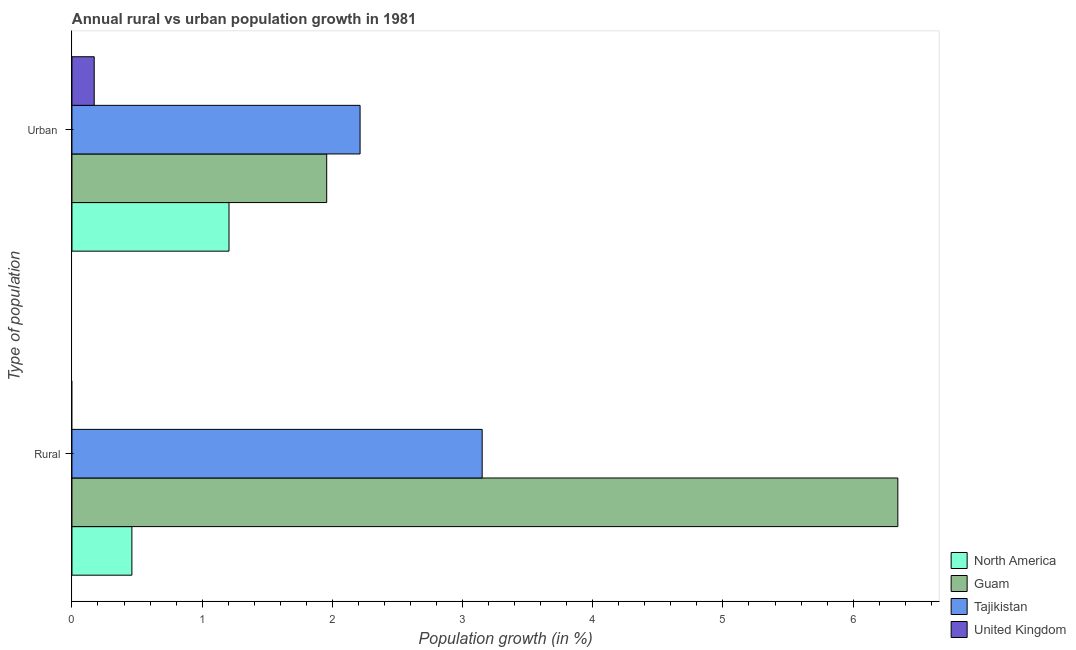How many groups of bars are there?
Ensure brevity in your answer.  2. How many bars are there on the 2nd tick from the bottom?
Offer a very short reply. 4. What is the label of the 1st group of bars from the top?
Your answer should be very brief. Urban . What is the rural population growth in North America?
Provide a succinct answer. 0.46. Across all countries, what is the maximum urban population growth?
Make the answer very short. 2.21. Across all countries, what is the minimum urban population growth?
Offer a terse response. 0.17. In which country was the rural population growth maximum?
Provide a short and direct response. Guam. What is the total urban population growth in the graph?
Provide a succinct answer. 5.55. What is the difference between the rural population growth in Guam and that in North America?
Give a very brief answer. 5.88. What is the difference between the urban population growth in Tajikistan and the rural population growth in United Kingdom?
Your answer should be compact. 2.21. What is the average rural population growth per country?
Keep it short and to the point. 2.49. What is the difference between the rural population growth and urban population growth in Tajikistan?
Give a very brief answer. 0.94. In how many countries, is the urban population growth greater than 5.4 %?
Offer a very short reply. 0. What is the ratio of the urban population growth in North America to that in Guam?
Provide a short and direct response. 0.62. How many bars are there?
Make the answer very short. 7. How many countries are there in the graph?
Offer a terse response. 4. Does the graph contain any zero values?
Make the answer very short. Yes. Does the graph contain grids?
Your response must be concise. No. What is the title of the graph?
Keep it short and to the point. Annual rural vs urban population growth in 1981. What is the label or title of the X-axis?
Your answer should be compact. Population growth (in %). What is the label or title of the Y-axis?
Ensure brevity in your answer.  Type of population. What is the Population growth (in %) in North America in Rural?
Make the answer very short. 0.46. What is the Population growth (in %) of Guam in Rural?
Make the answer very short. 6.34. What is the Population growth (in %) in Tajikistan in Rural?
Offer a terse response. 3.15. What is the Population growth (in %) of North America in Urban ?
Your response must be concise. 1.21. What is the Population growth (in %) in Guam in Urban ?
Give a very brief answer. 1.96. What is the Population growth (in %) in Tajikistan in Urban ?
Your answer should be very brief. 2.21. What is the Population growth (in %) of United Kingdom in Urban ?
Your answer should be compact. 0.17. Across all Type of population, what is the maximum Population growth (in %) of North America?
Give a very brief answer. 1.21. Across all Type of population, what is the maximum Population growth (in %) in Guam?
Your answer should be compact. 6.34. Across all Type of population, what is the maximum Population growth (in %) of Tajikistan?
Provide a short and direct response. 3.15. Across all Type of population, what is the maximum Population growth (in %) of United Kingdom?
Ensure brevity in your answer.  0.17. Across all Type of population, what is the minimum Population growth (in %) in North America?
Offer a very short reply. 0.46. Across all Type of population, what is the minimum Population growth (in %) in Guam?
Keep it short and to the point. 1.96. Across all Type of population, what is the minimum Population growth (in %) in Tajikistan?
Ensure brevity in your answer.  2.21. What is the total Population growth (in %) of North America in the graph?
Provide a short and direct response. 1.67. What is the total Population growth (in %) of Guam in the graph?
Ensure brevity in your answer.  8.3. What is the total Population growth (in %) of Tajikistan in the graph?
Your answer should be compact. 5.36. What is the total Population growth (in %) in United Kingdom in the graph?
Provide a short and direct response. 0.17. What is the difference between the Population growth (in %) in North America in Rural and that in Urban ?
Keep it short and to the point. -0.75. What is the difference between the Population growth (in %) of Guam in Rural and that in Urban ?
Provide a succinct answer. 4.39. What is the difference between the Population growth (in %) of Tajikistan in Rural and that in Urban ?
Your answer should be very brief. 0.94. What is the difference between the Population growth (in %) in North America in Rural and the Population growth (in %) in Guam in Urban ?
Provide a succinct answer. -1.5. What is the difference between the Population growth (in %) in North America in Rural and the Population growth (in %) in Tajikistan in Urban ?
Make the answer very short. -1.75. What is the difference between the Population growth (in %) of North America in Rural and the Population growth (in %) of United Kingdom in Urban ?
Your answer should be compact. 0.29. What is the difference between the Population growth (in %) of Guam in Rural and the Population growth (in %) of Tajikistan in Urban ?
Provide a short and direct response. 4.13. What is the difference between the Population growth (in %) of Guam in Rural and the Population growth (in %) of United Kingdom in Urban ?
Provide a succinct answer. 6.17. What is the difference between the Population growth (in %) in Tajikistan in Rural and the Population growth (in %) in United Kingdom in Urban ?
Ensure brevity in your answer.  2.98. What is the average Population growth (in %) in North America per Type of population?
Offer a terse response. 0.83. What is the average Population growth (in %) in Guam per Type of population?
Provide a succinct answer. 4.15. What is the average Population growth (in %) of Tajikistan per Type of population?
Offer a very short reply. 2.68. What is the average Population growth (in %) in United Kingdom per Type of population?
Make the answer very short. 0.09. What is the difference between the Population growth (in %) of North America and Population growth (in %) of Guam in Rural?
Offer a terse response. -5.88. What is the difference between the Population growth (in %) in North America and Population growth (in %) in Tajikistan in Rural?
Ensure brevity in your answer.  -2.69. What is the difference between the Population growth (in %) of Guam and Population growth (in %) of Tajikistan in Rural?
Your answer should be compact. 3.19. What is the difference between the Population growth (in %) of North America and Population growth (in %) of Guam in Urban ?
Offer a terse response. -0.75. What is the difference between the Population growth (in %) in North America and Population growth (in %) in Tajikistan in Urban ?
Offer a very short reply. -1.01. What is the difference between the Population growth (in %) of North America and Population growth (in %) of United Kingdom in Urban ?
Provide a succinct answer. 1.04. What is the difference between the Population growth (in %) in Guam and Population growth (in %) in Tajikistan in Urban ?
Your response must be concise. -0.26. What is the difference between the Population growth (in %) of Guam and Population growth (in %) of United Kingdom in Urban ?
Provide a succinct answer. 1.79. What is the difference between the Population growth (in %) in Tajikistan and Population growth (in %) in United Kingdom in Urban ?
Your response must be concise. 2.04. What is the ratio of the Population growth (in %) of North America in Rural to that in Urban ?
Keep it short and to the point. 0.38. What is the ratio of the Population growth (in %) of Guam in Rural to that in Urban ?
Ensure brevity in your answer.  3.24. What is the ratio of the Population growth (in %) of Tajikistan in Rural to that in Urban ?
Offer a terse response. 1.42. What is the difference between the highest and the second highest Population growth (in %) in North America?
Offer a very short reply. 0.75. What is the difference between the highest and the second highest Population growth (in %) of Guam?
Offer a terse response. 4.39. What is the difference between the highest and the second highest Population growth (in %) of Tajikistan?
Provide a short and direct response. 0.94. What is the difference between the highest and the lowest Population growth (in %) in North America?
Give a very brief answer. 0.75. What is the difference between the highest and the lowest Population growth (in %) of Guam?
Make the answer very short. 4.39. What is the difference between the highest and the lowest Population growth (in %) of Tajikistan?
Your response must be concise. 0.94. What is the difference between the highest and the lowest Population growth (in %) in United Kingdom?
Offer a terse response. 0.17. 